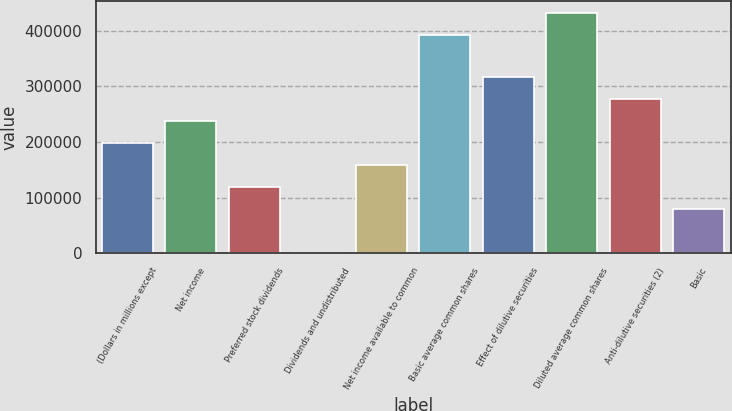<chart> <loc_0><loc_0><loc_500><loc_500><bar_chart><fcel>(Dollars in millions except<fcel>Net income<fcel>Preferred stock dividends<fcel>Dividends and undistributed<fcel>Net income available to common<fcel>Basic average common shares<fcel>Effect of dilutive securities<fcel>Diluted average common shares<fcel>Anti-dilutive securities (2)<fcel>Basic<nl><fcel>198046<fcel>237655<fcel>118828<fcel>2<fcel>158437<fcel>391485<fcel>316872<fcel>431094<fcel>277264<fcel>79219.6<nl></chart> 